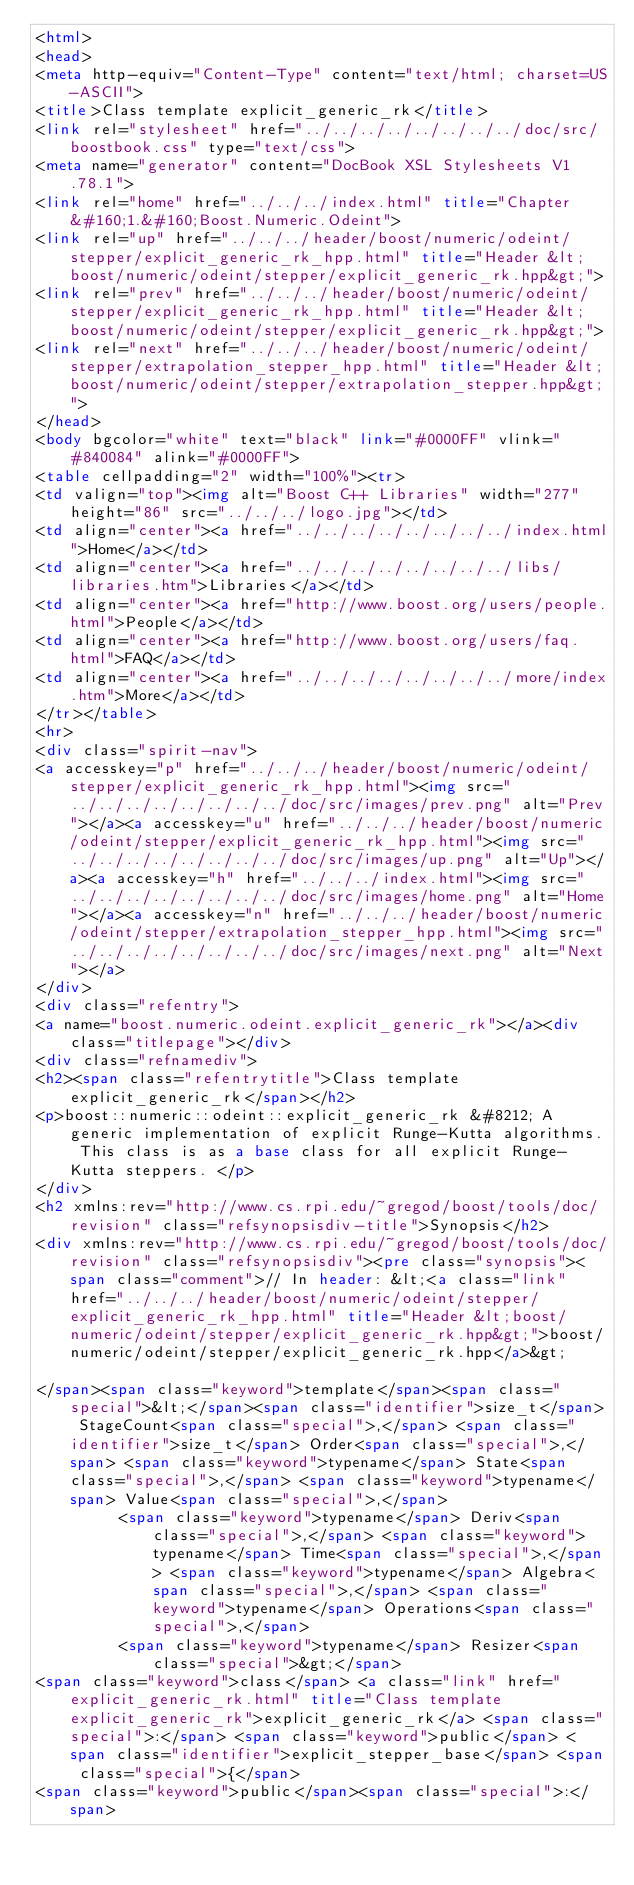Convert code to text. <code><loc_0><loc_0><loc_500><loc_500><_HTML_><html>
<head>
<meta http-equiv="Content-Type" content="text/html; charset=US-ASCII">
<title>Class template explicit_generic_rk</title>
<link rel="stylesheet" href="../../../../../../../../doc/src/boostbook.css" type="text/css">
<meta name="generator" content="DocBook XSL Stylesheets V1.78.1">
<link rel="home" href="../../../index.html" title="Chapter&#160;1.&#160;Boost.Numeric.Odeint">
<link rel="up" href="../../../header/boost/numeric/odeint/stepper/explicit_generic_rk_hpp.html" title="Header &lt;boost/numeric/odeint/stepper/explicit_generic_rk.hpp&gt;">
<link rel="prev" href="../../../header/boost/numeric/odeint/stepper/explicit_generic_rk_hpp.html" title="Header &lt;boost/numeric/odeint/stepper/explicit_generic_rk.hpp&gt;">
<link rel="next" href="../../../header/boost/numeric/odeint/stepper/extrapolation_stepper_hpp.html" title="Header &lt;boost/numeric/odeint/stepper/extrapolation_stepper.hpp&gt;">
</head>
<body bgcolor="white" text="black" link="#0000FF" vlink="#840084" alink="#0000FF">
<table cellpadding="2" width="100%"><tr>
<td valign="top"><img alt="Boost C++ Libraries" width="277" height="86" src="../../../logo.jpg"></td>
<td align="center"><a href="../../../../../../../../index.html">Home</a></td>
<td align="center"><a href="../../../../../../../../libs/libraries.htm">Libraries</a></td>
<td align="center"><a href="http://www.boost.org/users/people.html">People</a></td>
<td align="center"><a href="http://www.boost.org/users/faq.html">FAQ</a></td>
<td align="center"><a href="../../../../../../../../more/index.htm">More</a></td>
</tr></table>
<hr>
<div class="spirit-nav">
<a accesskey="p" href="../../../header/boost/numeric/odeint/stepper/explicit_generic_rk_hpp.html"><img src="../../../../../../../../doc/src/images/prev.png" alt="Prev"></a><a accesskey="u" href="../../../header/boost/numeric/odeint/stepper/explicit_generic_rk_hpp.html"><img src="../../../../../../../../doc/src/images/up.png" alt="Up"></a><a accesskey="h" href="../../../index.html"><img src="../../../../../../../../doc/src/images/home.png" alt="Home"></a><a accesskey="n" href="../../../header/boost/numeric/odeint/stepper/extrapolation_stepper_hpp.html"><img src="../../../../../../../../doc/src/images/next.png" alt="Next"></a>
</div>
<div class="refentry">
<a name="boost.numeric.odeint.explicit_generic_rk"></a><div class="titlepage"></div>
<div class="refnamediv">
<h2><span class="refentrytitle">Class template explicit_generic_rk</span></h2>
<p>boost::numeric::odeint::explicit_generic_rk &#8212; A generic implementation of explicit Runge-Kutta algorithms. This class is as a base class for all explicit Runge-Kutta steppers. </p>
</div>
<h2 xmlns:rev="http://www.cs.rpi.edu/~gregod/boost/tools/doc/revision" class="refsynopsisdiv-title">Synopsis</h2>
<div xmlns:rev="http://www.cs.rpi.edu/~gregod/boost/tools/doc/revision" class="refsynopsisdiv"><pre class="synopsis"><span class="comment">// In header: &lt;<a class="link" href="../../../header/boost/numeric/odeint/stepper/explicit_generic_rk_hpp.html" title="Header &lt;boost/numeric/odeint/stepper/explicit_generic_rk.hpp&gt;">boost/numeric/odeint/stepper/explicit_generic_rk.hpp</a>&gt;

</span><span class="keyword">template</span><span class="special">&lt;</span><span class="identifier">size_t</span> StageCount<span class="special">,</span> <span class="identifier">size_t</span> Order<span class="special">,</span> <span class="keyword">typename</span> State<span class="special">,</span> <span class="keyword">typename</span> Value<span class="special">,</span> 
         <span class="keyword">typename</span> Deriv<span class="special">,</span> <span class="keyword">typename</span> Time<span class="special">,</span> <span class="keyword">typename</span> Algebra<span class="special">,</span> <span class="keyword">typename</span> Operations<span class="special">,</span> 
         <span class="keyword">typename</span> Resizer<span class="special">&gt;</span> 
<span class="keyword">class</span> <a class="link" href="explicit_generic_rk.html" title="Class template explicit_generic_rk">explicit_generic_rk</a> <span class="special">:</span> <span class="keyword">public</span> <span class="identifier">explicit_stepper_base</span> <span class="special">{</span>
<span class="keyword">public</span><span class="special">:</span></code> 